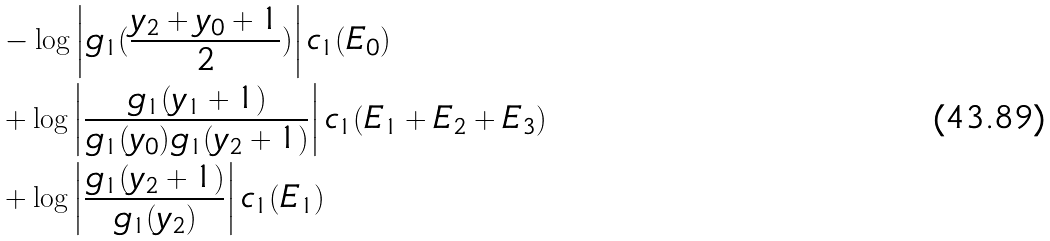<formula> <loc_0><loc_0><loc_500><loc_500>& - \log \left | g _ { 1 } ( \frac { y _ { 2 } + y _ { 0 } + 1 } { 2 } ) \right | c _ { 1 } ( E _ { 0 } ) \\ & + \log \left | \frac { g _ { 1 } ( y _ { 1 } + 1 ) } { g _ { 1 } ( y _ { 0 } ) g _ { 1 } ( y _ { 2 } + 1 ) } \right | c _ { 1 } ( E _ { 1 } + E _ { 2 } + E _ { 3 } ) \\ & + \log \left | \frac { g _ { 1 } ( y _ { 2 } + 1 ) } { g _ { 1 } ( y _ { 2 } ) } \right | c _ { 1 } ( E _ { 1 } )</formula> 